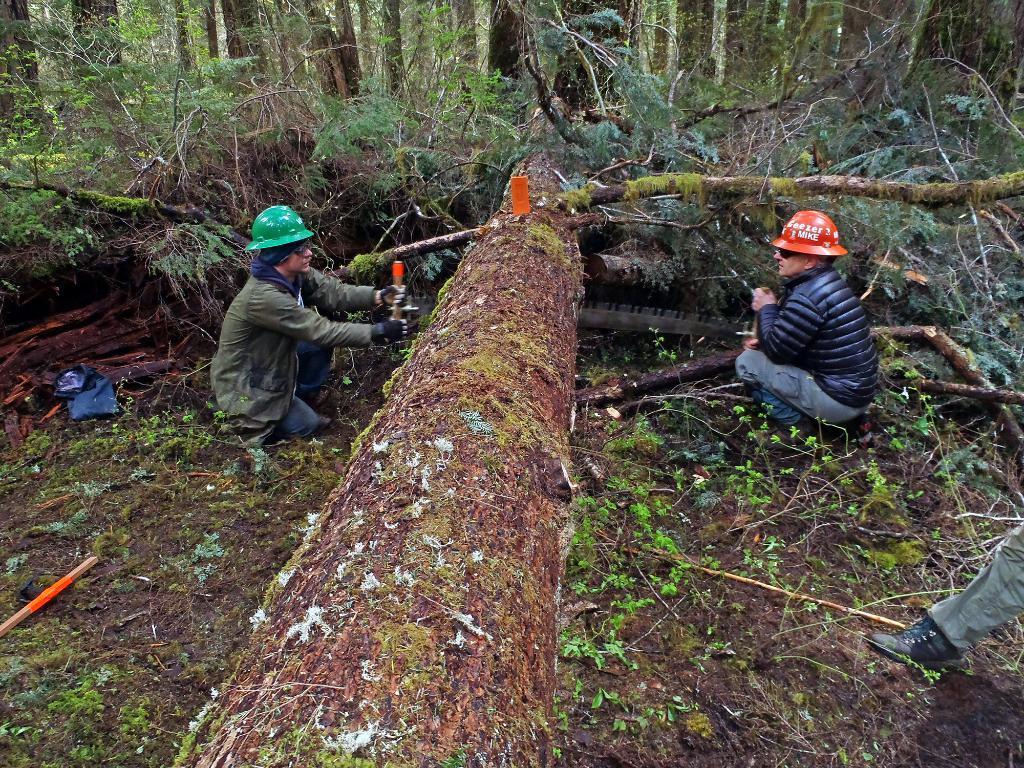How would you summarize this image in a sentence or two? In this image we can see group of persons standing on the ground. Two persons are cutting a tree with a knife in there hand. In the background we can see group of trees. 